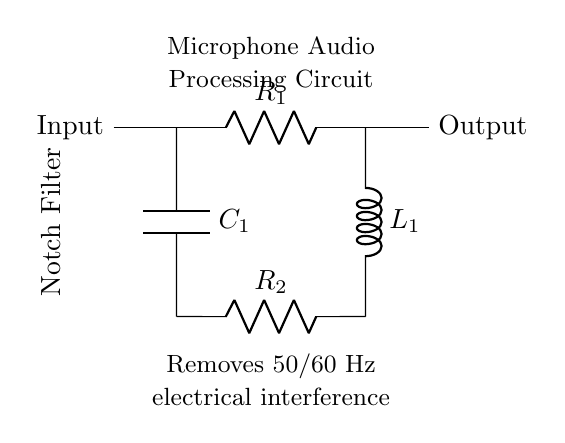What type of filter is depicted? The diagram shows a notch filter, which is indicated in the label to the left of the circuit diagram. A notch filter specifically targets and removes specific frequency signals from an input.
Answer: Notch filter What frequencies does this filter remove? The circuit indicates that it removes 50/60 Hz electrical interference, as noted in the description within the diagram. This frequency is commonly associated with AC power interference.
Answer: 50/60 Hz How many resistors are present in the circuit? The diagram contains two resistors labeled R1 and R2, both of which are represented within the circuit connections.
Answer: 2 What are the components of this notch filter? The components of the notch filter include two resistors (R1 and R2), one capacitor (C1), and one inductor (L1) as indicated in the circuit diagram. Each component serves a role in filtering the specific interfering frequency.
Answer: Resistors, capacitor, inductor How is the output labeled in the circuit? The output of the circuit is labeled as 'Output' on the right-hand side, which indicates where the processed signal exits the filter after interference removal.
Answer: Output What is the purpose of the described circuit? The purpose of the circuit is to remove electrical interference from microphone audio, which is specified in the description of the circuit. This is essential for clear audio during interviews.
Answer: Removes electrical interference 